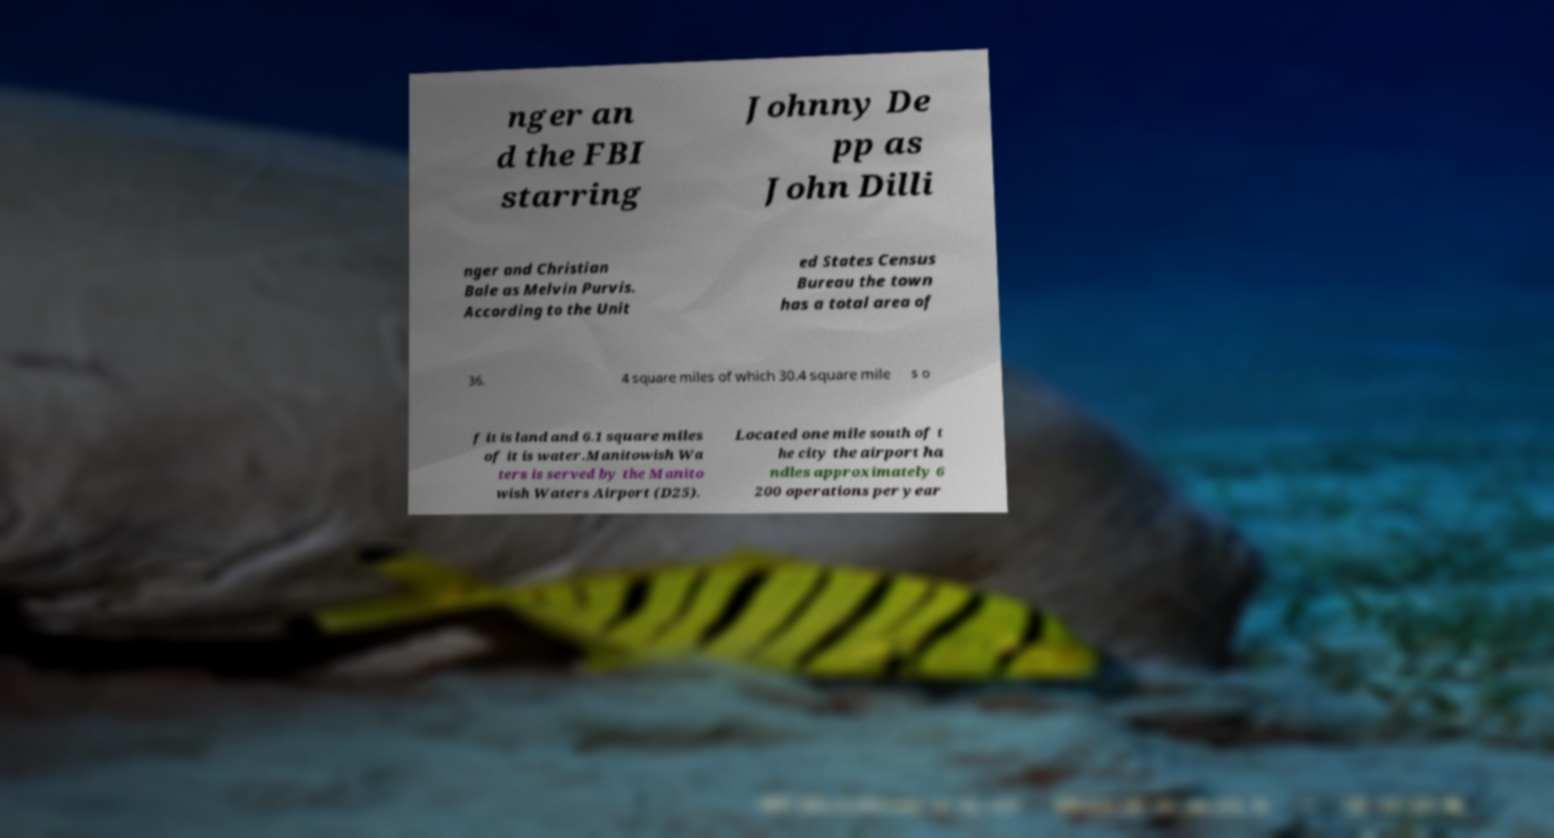For documentation purposes, I need the text within this image transcribed. Could you provide that? nger an d the FBI starring Johnny De pp as John Dilli nger and Christian Bale as Melvin Purvis. According to the Unit ed States Census Bureau the town has a total area of 36. 4 square miles of which 30.4 square mile s o f it is land and 6.1 square miles of it is water.Manitowish Wa ters is served by the Manito wish Waters Airport (D25). Located one mile south of t he city the airport ha ndles approximately 6 200 operations per year 